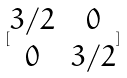Convert formula to latex. <formula><loc_0><loc_0><loc_500><loc_500>[ \begin{matrix} 3 / 2 & 0 \\ 0 & 3 / 2 \end{matrix} ]</formula> 